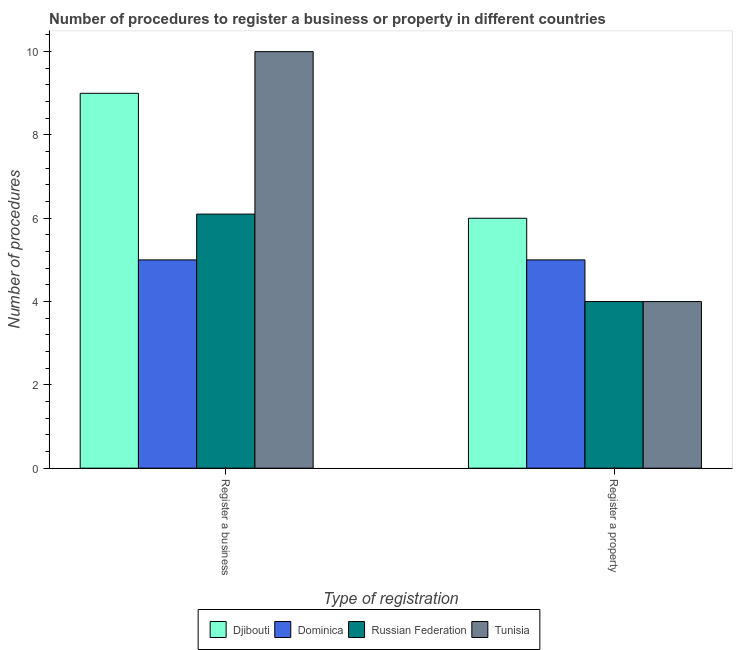How many different coloured bars are there?
Offer a terse response. 4. Are the number of bars per tick equal to the number of legend labels?
Provide a succinct answer. Yes. Are the number of bars on each tick of the X-axis equal?
Your response must be concise. Yes. How many bars are there on the 2nd tick from the right?
Offer a terse response. 4. What is the label of the 1st group of bars from the left?
Make the answer very short. Register a business. What is the number of procedures to register a property in Djibouti?
Your answer should be compact. 6. Across all countries, what is the maximum number of procedures to register a business?
Ensure brevity in your answer.  10. Across all countries, what is the minimum number of procedures to register a property?
Ensure brevity in your answer.  4. In which country was the number of procedures to register a business maximum?
Your response must be concise. Tunisia. In which country was the number of procedures to register a property minimum?
Make the answer very short. Russian Federation. What is the total number of procedures to register a business in the graph?
Keep it short and to the point. 30.1. What is the difference between the number of procedures to register a property in Djibouti and that in Russian Federation?
Your answer should be compact. 2. What is the difference between the number of procedures to register a business in Djibouti and the number of procedures to register a property in Russian Federation?
Offer a very short reply. 5. What is the average number of procedures to register a business per country?
Keep it short and to the point. 7.53. What is the difference between the number of procedures to register a property and number of procedures to register a business in Russian Federation?
Your answer should be very brief. -2.1. What is the ratio of the number of procedures to register a property in Tunisia to that in Russian Federation?
Your response must be concise. 1. In how many countries, is the number of procedures to register a property greater than the average number of procedures to register a property taken over all countries?
Provide a short and direct response. 2. What does the 1st bar from the left in Register a business represents?
Offer a terse response. Djibouti. What does the 2nd bar from the right in Register a business represents?
Your response must be concise. Russian Federation. Are all the bars in the graph horizontal?
Keep it short and to the point. No. How many countries are there in the graph?
Offer a very short reply. 4. Where does the legend appear in the graph?
Your answer should be compact. Bottom center. How are the legend labels stacked?
Your response must be concise. Horizontal. What is the title of the graph?
Offer a very short reply. Number of procedures to register a business or property in different countries. What is the label or title of the X-axis?
Your answer should be compact. Type of registration. What is the label or title of the Y-axis?
Offer a terse response. Number of procedures. What is the Number of procedures of Dominica in Register a business?
Ensure brevity in your answer.  5. What is the Number of procedures in Dominica in Register a property?
Your response must be concise. 5. What is the Number of procedures in Tunisia in Register a property?
Keep it short and to the point. 4. Across all Type of registration, what is the maximum Number of procedures in Djibouti?
Keep it short and to the point. 9. Across all Type of registration, what is the maximum Number of procedures in Dominica?
Keep it short and to the point. 5. Across all Type of registration, what is the maximum Number of procedures in Russian Federation?
Your answer should be compact. 6.1. Across all Type of registration, what is the maximum Number of procedures in Tunisia?
Ensure brevity in your answer.  10. Across all Type of registration, what is the minimum Number of procedures of Djibouti?
Provide a short and direct response. 6. Across all Type of registration, what is the minimum Number of procedures in Russian Federation?
Offer a very short reply. 4. What is the total Number of procedures of Djibouti in the graph?
Provide a short and direct response. 15. What is the total Number of procedures of Dominica in the graph?
Give a very brief answer. 10. What is the total Number of procedures of Russian Federation in the graph?
Provide a short and direct response. 10.1. What is the difference between the Number of procedures in Dominica in Register a business and that in Register a property?
Give a very brief answer. 0. What is the difference between the Number of procedures of Russian Federation in Register a business and that in Register a property?
Ensure brevity in your answer.  2.1. What is the difference between the Number of procedures in Djibouti in Register a business and the Number of procedures in Dominica in Register a property?
Ensure brevity in your answer.  4. What is the difference between the Number of procedures in Djibouti in Register a business and the Number of procedures in Russian Federation in Register a property?
Your answer should be compact. 5. What is the difference between the Number of procedures of Djibouti in Register a business and the Number of procedures of Tunisia in Register a property?
Offer a very short reply. 5. What is the difference between the Number of procedures of Russian Federation in Register a business and the Number of procedures of Tunisia in Register a property?
Offer a very short reply. 2.1. What is the average Number of procedures of Djibouti per Type of registration?
Your answer should be compact. 7.5. What is the average Number of procedures in Dominica per Type of registration?
Your answer should be very brief. 5. What is the average Number of procedures in Russian Federation per Type of registration?
Keep it short and to the point. 5.05. What is the difference between the Number of procedures of Djibouti and Number of procedures of Dominica in Register a business?
Offer a very short reply. 4. What is the difference between the Number of procedures of Dominica and Number of procedures of Russian Federation in Register a business?
Your response must be concise. -1.1. What is the difference between the Number of procedures of Dominica and Number of procedures of Tunisia in Register a business?
Your answer should be very brief. -5. What is the difference between the Number of procedures of Russian Federation and Number of procedures of Tunisia in Register a business?
Provide a succinct answer. -3.9. What is the difference between the Number of procedures of Djibouti and Number of procedures of Russian Federation in Register a property?
Provide a short and direct response. 2. What is the difference between the Number of procedures in Djibouti and Number of procedures in Tunisia in Register a property?
Offer a terse response. 2. What is the difference between the Number of procedures in Russian Federation and Number of procedures in Tunisia in Register a property?
Offer a terse response. 0. What is the ratio of the Number of procedures of Djibouti in Register a business to that in Register a property?
Make the answer very short. 1.5. What is the ratio of the Number of procedures of Dominica in Register a business to that in Register a property?
Give a very brief answer. 1. What is the ratio of the Number of procedures of Russian Federation in Register a business to that in Register a property?
Offer a terse response. 1.52. What is the difference between the highest and the second highest Number of procedures in Djibouti?
Provide a succinct answer. 3. What is the difference between the highest and the second highest Number of procedures of Dominica?
Offer a terse response. 0. What is the difference between the highest and the second highest Number of procedures of Russian Federation?
Make the answer very short. 2.1. What is the difference between the highest and the second highest Number of procedures of Tunisia?
Provide a succinct answer. 6. What is the difference between the highest and the lowest Number of procedures in Djibouti?
Ensure brevity in your answer.  3. What is the difference between the highest and the lowest Number of procedures of Dominica?
Your answer should be very brief. 0. What is the difference between the highest and the lowest Number of procedures in Russian Federation?
Ensure brevity in your answer.  2.1. 